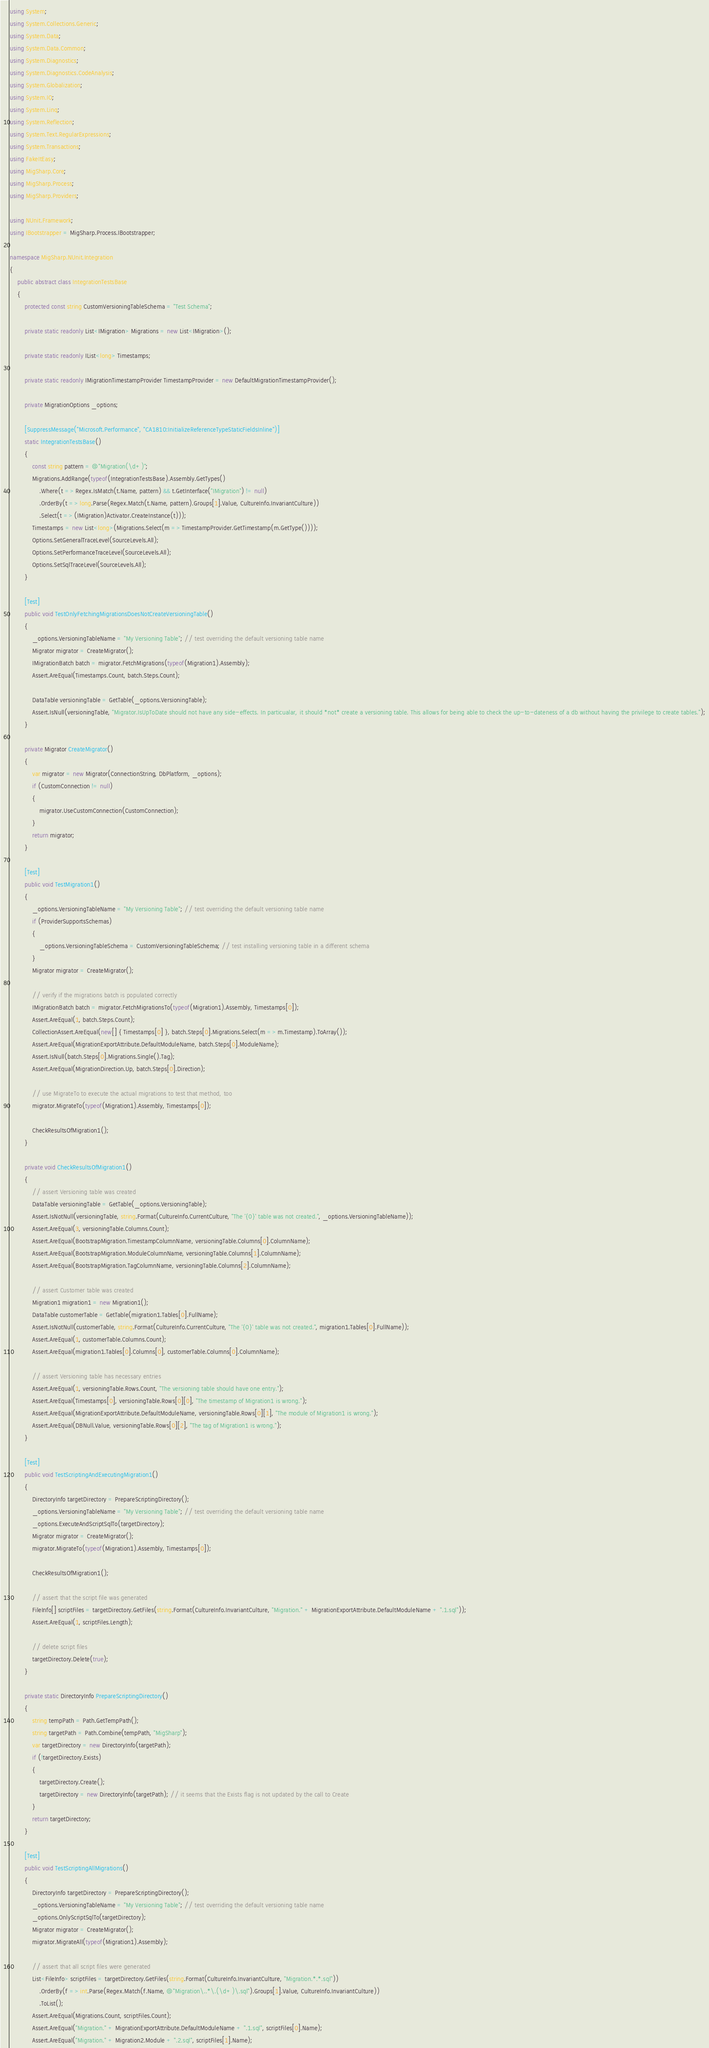Convert code to text. <code><loc_0><loc_0><loc_500><loc_500><_C#_>using System;
using System.Collections.Generic;
using System.Data;
using System.Data.Common;
using System.Diagnostics;
using System.Diagnostics.CodeAnalysis;
using System.Globalization;
using System.IO;
using System.Linq;
using System.Reflection;
using System.Text.RegularExpressions;
using System.Transactions;
using FakeItEasy;
using MigSharp.Core;
using MigSharp.Process;
using MigSharp.Providers;

using NUnit.Framework;
using IBootstrapper = MigSharp.Process.IBootstrapper;

namespace MigSharp.NUnit.Integration
{
    public abstract class IntegrationTestsBase
    {
        protected const string CustomVersioningTableSchema = "Test Schema";

        private static readonly List<IMigration> Migrations = new List<IMigration>();

        private static readonly IList<long> Timestamps;

        private static readonly IMigrationTimestampProvider TimestampProvider = new DefaultMigrationTimestampProvider();

        private MigrationOptions _options;

        [SuppressMessage("Microsoft.Performance", "CA1810:InitializeReferenceTypeStaticFieldsInline")]
        static IntegrationTestsBase()
        {
            const string pattern = @"Migration(\d+)";
            Migrations.AddRange(typeof(IntegrationTestsBase).Assembly.GetTypes()
                .Where(t => Regex.IsMatch(t.Name, pattern) && t.GetInterface("IMigration") != null)
                .OrderBy(t => long.Parse(Regex.Match(t.Name, pattern).Groups[1].Value, CultureInfo.InvariantCulture))
                .Select(t => (IMigration)Activator.CreateInstance(t)));
            Timestamps = new List<long>(Migrations.Select(m => TimestampProvider.GetTimestamp(m.GetType())));
            Options.SetGeneralTraceLevel(SourceLevels.All);
            Options.SetPerformanceTraceLevel(SourceLevels.All);
            Options.SetSqlTraceLevel(SourceLevels.All);
        }

        [Test]
        public void TestOnlyFetchingMigrationsDoesNotCreateVersioningTable()
        {
            _options.VersioningTableName = "My Versioning Table"; // test overriding the default versioning table name
            Migrator migrator = CreateMigrator();
            IMigrationBatch batch = migrator.FetchMigrations(typeof(Migration1).Assembly);
            Assert.AreEqual(Timestamps.Count, batch.Steps.Count);

            DataTable versioningTable = GetTable(_options.VersioningTable);
            Assert.IsNull(versioningTable, "Migrator.IsUpToDate should not have any side-effects. In particualar, it should *not* create a versioning table. This allows for being able to check the up-to-dateness of a db without having the privilege to create tables.");
        }

        private Migrator CreateMigrator()
        {
            var migrator = new Migrator(ConnectionString, DbPlatform, _options);
            if (CustomConnection != null)
            {
                migrator.UseCustomConnection(CustomConnection);
            }
            return migrator;
        }

        [Test]
        public void TestMigration1()
        {
            _options.VersioningTableName = "My Versioning Table"; // test overriding the default versioning table name
            if (ProviderSupportsSchemas)
            {
                _options.VersioningTableSchema = CustomVersioningTableSchema; // test installing versioning table in a different schema
            }
            Migrator migrator = CreateMigrator();

            // verify if the migrations batch is populated correctly
            IMigrationBatch batch = migrator.FetchMigrationsTo(typeof(Migration1).Assembly, Timestamps[0]);
            Assert.AreEqual(1, batch.Steps.Count);
            CollectionAssert.AreEqual(new[] { Timestamps[0] }, batch.Steps[0].Migrations.Select(m => m.Timestamp).ToArray());
            Assert.AreEqual(MigrationExportAttribute.DefaultModuleName, batch.Steps[0].ModuleName);
            Assert.IsNull(batch.Steps[0].Migrations.Single().Tag);
            Assert.AreEqual(MigrationDirection.Up, batch.Steps[0].Direction);

            // use MigrateTo to execute the actual migrations to test that method, too
            migrator.MigrateTo(typeof(Migration1).Assembly, Timestamps[0]);

            CheckResultsOfMigration1();
        }

        private void CheckResultsOfMigration1()
        {
            // assert Versioning table was created
            DataTable versioningTable = GetTable(_options.VersioningTable);
            Assert.IsNotNull(versioningTable, string.Format(CultureInfo.CurrentCulture, "The '{0}' table was not created.", _options.VersioningTableName));
            Assert.AreEqual(3, versioningTable.Columns.Count);
            Assert.AreEqual(BootstrapMigration.TimestampColumnName, versioningTable.Columns[0].ColumnName);
            Assert.AreEqual(BootstrapMigration.ModuleColumnName, versioningTable.Columns[1].ColumnName);
            Assert.AreEqual(BootstrapMigration.TagColumnName, versioningTable.Columns[2].ColumnName);

            // assert Customer table was created
            Migration1 migration1 = new Migration1();
            DataTable customerTable = GetTable(migration1.Tables[0].FullName);
            Assert.IsNotNull(customerTable, string.Format(CultureInfo.CurrentCulture, "The '{0}' table was not created.", migration1.Tables[0].FullName));
            Assert.AreEqual(1, customerTable.Columns.Count);
            Assert.AreEqual(migration1.Tables[0].Columns[0], customerTable.Columns[0].ColumnName);

            // assert Versioning table has necessary entries
            Assert.AreEqual(1, versioningTable.Rows.Count, "The versioning table should have one entry.");
            Assert.AreEqual(Timestamps[0], versioningTable.Rows[0][0], "The timestamp of Migration1 is wrong.");
            Assert.AreEqual(MigrationExportAttribute.DefaultModuleName, versioningTable.Rows[0][1], "The module of Migration1 is wrong.");
            Assert.AreEqual(DBNull.Value, versioningTable.Rows[0][2], "The tag of Migration1 is wrong.");
        }

        [Test]
        public void TestScriptingAndExecutingMigration1()
        {
            DirectoryInfo targetDirectory = PrepareScriptingDirectory();
            _options.VersioningTableName = "My Versioning Table"; // test overriding the default versioning table name
            _options.ExecuteAndScriptSqlTo(targetDirectory);
            Migrator migrator = CreateMigrator();
            migrator.MigrateTo(typeof(Migration1).Assembly, Timestamps[0]);

            CheckResultsOfMigration1();

            // assert that the script file was generated
            FileInfo[] scriptFiles = targetDirectory.GetFiles(string.Format(CultureInfo.InvariantCulture, "Migration." + MigrationExportAttribute.DefaultModuleName + ".1.sql"));
            Assert.AreEqual(1, scriptFiles.Length);

            // delete script files
            targetDirectory.Delete(true);
        }

        private static DirectoryInfo PrepareScriptingDirectory()
        {
            string tempPath = Path.GetTempPath();
            string targetPath = Path.Combine(tempPath, "MigSharp");
            var targetDirectory = new DirectoryInfo(targetPath);
            if (!targetDirectory.Exists)
            {
                targetDirectory.Create();
                targetDirectory = new DirectoryInfo(targetPath); // it seems that the Exists flag is not updated by the call to Create
            }
            return targetDirectory;
        }

        [Test]
        public void TestScriptingAllMigrations()
        {
            DirectoryInfo targetDirectory = PrepareScriptingDirectory();
            _options.VersioningTableName = "My Versioning Table"; // test overriding the default versioning table name
            _options.OnlyScriptSqlTo(targetDirectory);
            Migrator migrator = CreateMigrator();
            migrator.MigrateAll(typeof(Migration1).Assembly);

            // assert that all script files were generated
            List<FileInfo> scriptFiles = targetDirectory.GetFiles(string.Format(CultureInfo.InvariantCulture, "Migration.*.*.sql"))
                .OrderBy(f => int.Parse(Regex.Match(f.Name, @"Migration\..*\.(\d+)\.sql").Groups[1].Value, CultureInfo.InvariantCulture))
                .ToList();
            Assert.AreEqual(Migrations.Count, scriptFiles.Count);
            Assert.AreEqual("Migration." + MigrationExportAttribute.DefaultModuleName + ".1.sql", scriptFiles[0].Name);
            Assert.AreEqual("Migration." + Migration2.Module + ".2.sql", scriptFiles[1].Name);
</code> 